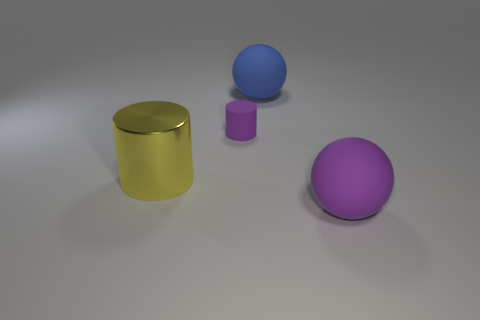Is there any other thing that is the same size as the rubber cylinder?
Your answer should be very brief. No. There is a purple matte thing behind the big yellow object; is it the same shape as the yellow metal thing?
Provide a succinct answer. Yes. How many blue objects are tiny matte cylinders or big objects?
Your response must be concise. 1. There is another small thing that is the same shape as the metallic object; what material is it?
Your answer should be compact. Rubber. There is a big thing in front of the big cylinder; what is its shape?
Provide a short and direct response. Sphere. Are there any blue objects that have the same material as the small cylinder?
Provide a succinct answer. Yes. Does the blue matte sphere have the same size as the purple cylinder?
Make the answer very short. No. How many cylinders are yellow metallic things or purple objects?
Provide a succinct answer. 2. There is a thing that is the same color as the rubber cylinder; what material is it?
Offer a terse response. Rubber. How many other rubber objects are the same shape as the big yellow thing?
Your answer should be compact. 1. 